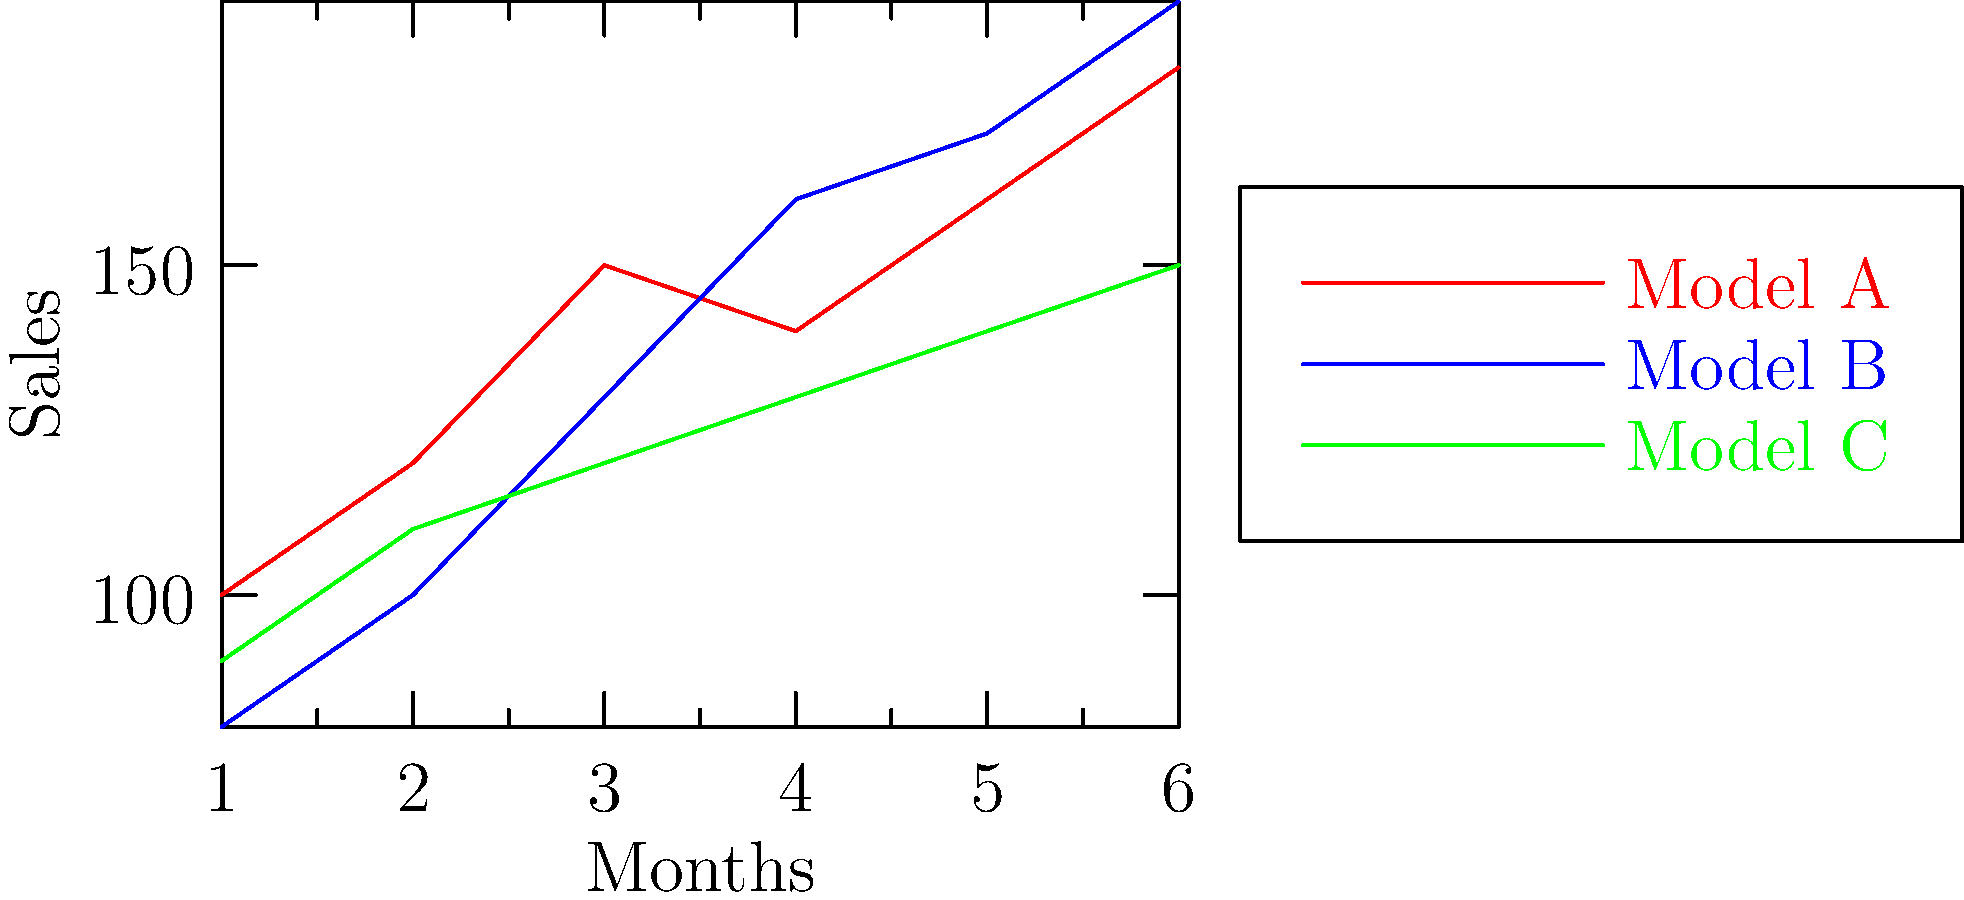Based on the sales trends shown in the line graph for three vacuum models over a six-month period, which model demonstrates the most consistent growth in sales? To determine which model shows the most consistent growth, we need to analyze the sales trends for each model:

1. Model A (red line):
   - Starts at 100 units
   - Shows rapid growth in the first 3 months
   - Experiences a slight dip in month 4
   - Resumes growth in months 5 and 6
   - Overall trend is positive but not entirely consistent

2. Model B (blue line):
   - Starts at 80 units
   - Shows steady growth for the first 4 months
   - Growth rate slows down in months 5 and 6
   - Overall trend is positive and relatively consistent

3. Model C (green line):
   - Starts at 90 units
   - Shows steady, linear growth throughout all 6 months
   - The line has the most consistent upward slope
   - Growth rate appears to be constant

Comparing these trends, Model C demonstrates the most consistent growth in sales. Its line shows a steady, uninterrupted increase over the entire six-month period, without any fluctuations or changes in growth rate.
Answer: Model C 